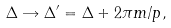Convert formula to latex. <formula><loc_0><loc_0><loc_500><loc_500>\Delta \rightarrow \Delta ^ { \prime } = \Delta + 2 \pi m / p ,</formula> 